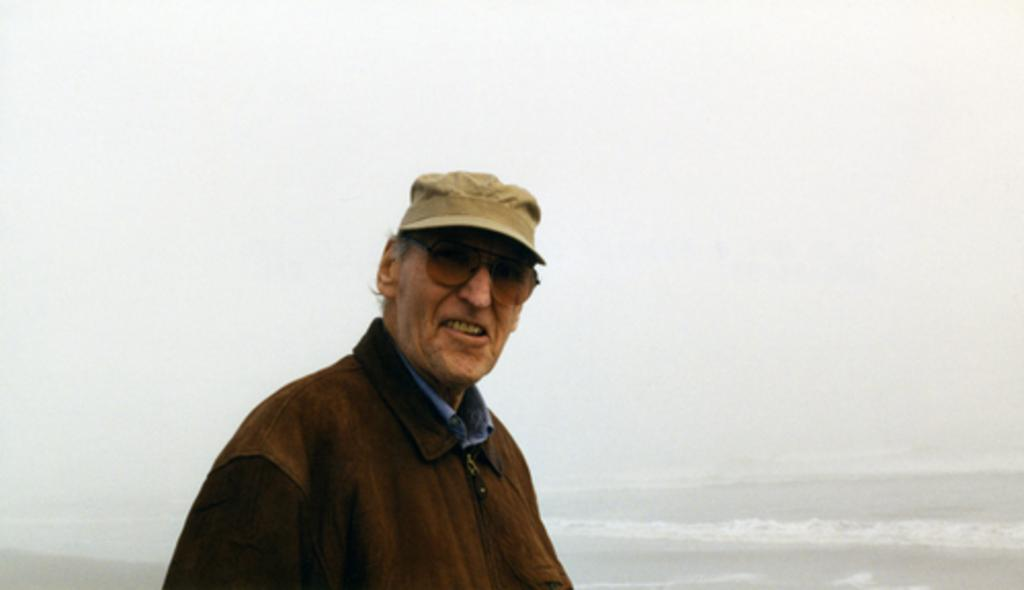Who is the main subject in the picture? There is an old man in the picture. What is the old man wearing on his head? The old man is wearing a cap. Where is the old man standing in the picture? The old man is standing in front of the sea. What is the old man's facial expression in the picture? The old man is smiling at someone. What type of grass can be seen in the downtown area in the image? There is no grass or downtown area present in the image; it features an old man standing in front of the sea. 